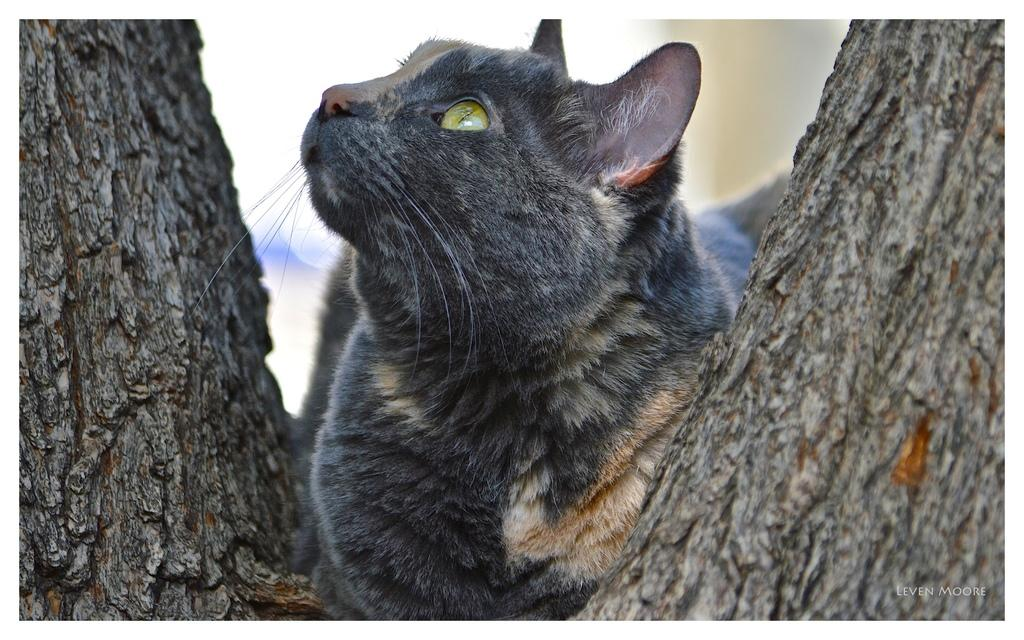What animal is present in the image? There is a cat in the image. Can you describe the color of the cat? The cat is black and gray in color. What is the cat sitting on in the image? The cat is sitting on a trunk. How many legs does the rail have in the image? There is no rail present in the image, so it is not possible to determine the number of legs it might have. 